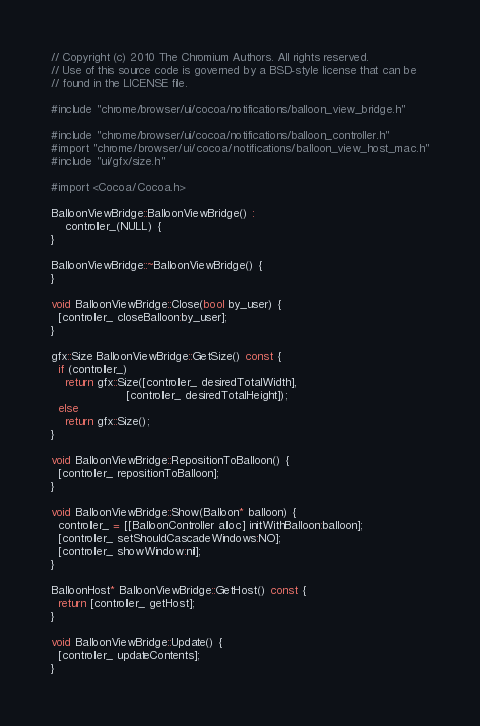<code> <loc_0><loc_0><loc_500><loc_500><_ObjectiveC_>// Copyright (c) 2010 The Chromium Authors. All rights reserved.
// Use of this source code is governed by a BSD-style license that can be
// found in the LICENSE file.

#include "chrome/browser/ui/cocoa/notifications/balloon_view_bridge.h"

#include "chrome/browser/ui/cocoa/notifications/balloon_controller.h"
#import "chrome/browser/ui/cocoa/notifications/balloon_view_host_mac.h"
#include "ui/gfx/size.h"

#import <Cocoa/Cocoa.h>

BalloonViewBridge::BalloonViewBridge() :
    controller_(NULL) {
}

BalloonViewBridge::~BalloonViewBridge() {
}

void BalloonViewBridge::Close(bool by_user) {
  [controller_ closeBalloon:by_user];
}

gfx::Size BalloonViewBridge::GetSize() const {
  if (controller_)
    return gfx::Size([controller_ desiredTotalWidth],
                     [controller_ desiredTotalHeight]);
  else
    return gfx::Size();
}

void BalloonViewBridge::RepositionToBalloon() {
  [controller_ repositionToBalloon];
}

void BalloonViewBridge::Show(Balloon* balloon) {
  controller_ = [[BalloonController alloc] initWithBalloon:balloon];
  [controller_ setShouldCascadeWindows:NO];
  [controller_ showWindow:nil];
}

BalloonHost* BalloonViewBridge::GetHost() const {
  return [controller_ getHost];
}

void BalloonViewBridge::Update() {
  [controller_ updateContents];
}
</code> 